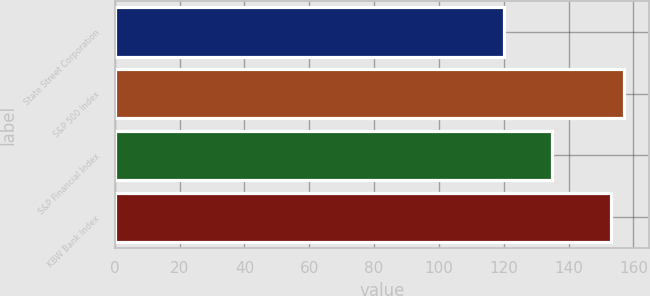Convert chart to OTSL. <chart><loc_0><loc_0><loc_500><loc_500><bar_chart><fcel>State Street Corporation<fcel>S&P 500 Index<fcel>S&P Financial Index<fcel>KBW Bank Index<nl><fcel>120<fcel>157<fcel>135<fcel>153<nl></chart> 